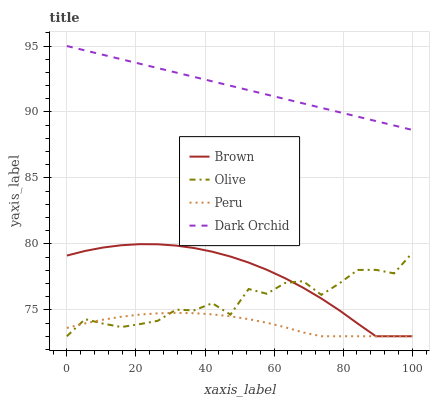Does Peru have the minimum area under the curve?
Answer yes or no. Yes. Does Dark Orchid have the maximum area under the curve?
Answer yes or no. Yes. Does Brown have the minimum area under the curve?
Answer yes or no. No. Does Brown have the maximum area under the curve?
Answer yes or no. No. Is Dark Orchid the smoothest?
Answer yes or no. Yes. Is Olive the roughest?
Answer yes or no. Yes. Is Brown the smoothest?
Answer yes or no. No. Is Brown the roughest?
Answer yes or no. No. Does Olive have the lowest value?
Answer yes or no. Yes. Does Dark Orchid have the lowest value?
Answer yes or no. No. Does Dark Orchid have the highest value?
Answer yes or no. Yes. Does Brown have the highest value?
Answer yes or no. No. Is Olive less than Dark Orchid?
Answer yes or no. Yes. Is Dark Orchid greater than Brown?
Answer yes or no. Yes. Does Olive intersect Brown?
Answer yes or no. Yes. Is Olive less than Brown?
Answer yes or no. No. Is Olive greater than Brown?
Answer yes or no. No. Does Olive intersect Dark Orchid?
Answer yes or no. No. 